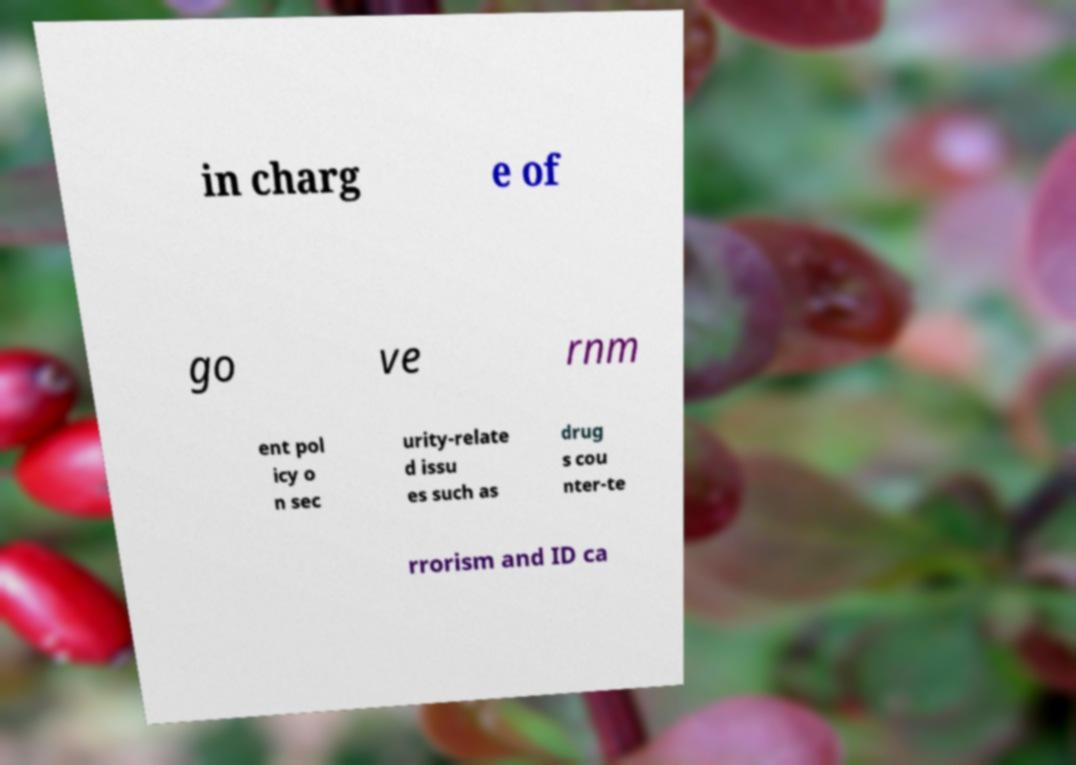Can you accurately transcribe the text from the provided image for me? in charg e of go ve rnm ent pol icy o n sec urity-relate d issu es such as drug s cou nter-te rrorism and ID ca 